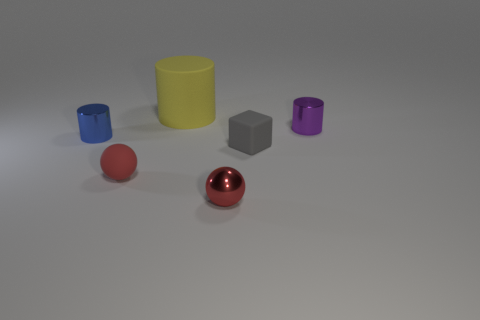Are there any other things that have the same size as the yellow cylinder?
Keep it short and to the point. No. Do the red shiny thing and the blue cylinder have the same size?
Ensure brevity in your answer.  Yes. How many gray cubes are the same material as the small purple cylinder?
Ensure brevity in your answer.  0. There is a blue thing that is the same shape as the small purple metallic object; what size is it?
Your response must be concise. Small. Do the small metallic object behind the blue metal cylinder and the gray rubber thing have the same shape?
Your answer should be very brief. No. What shape is the rubber object that is to the left of the cylinder behind the small purple thing?
Offer a very short reply. Sphere. Is there anything else that is the same shape as the tiny red matte object?
Make the answer very short. Yes. There is a metal object that is the same shape as the red matte thing; what is its color?
Keep it short and to the point. Red. There is a block; is its color the same as the rubber object that is behind the blue metallic thing?
Your response must be concise. No. There is a small metallic object that is both to the right of the big cylinder and in front of the small purple object; what is its shape?
Ensure brevity in your answer.  Sphere. 